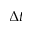<formula> <loc_0><loc_0><loc_500><loc_500>\Delta t</formula> 